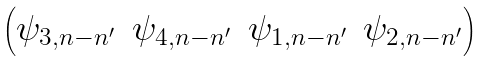<formula> <loc_0><loc_0><loc_500><loc_500>\begin{pmatrix} \psi _ { 3 , n - n ^ { \prime } } & \psi _ { 4 , n - n ^ { \prime } } & \psi _ { 1 , n - n ^ { \prime } } & \psi _ { 2 , n - n ^ { \prime } } \\ \end{pmatrix}</formula> 